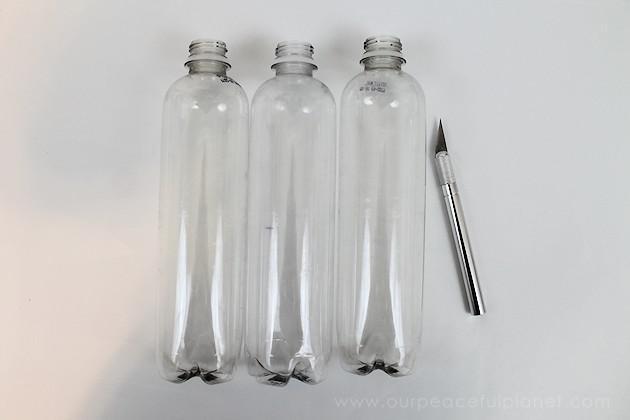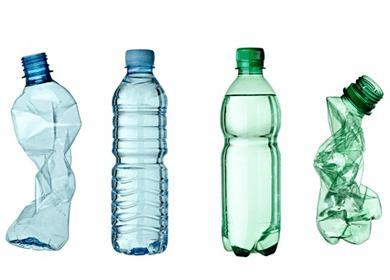The first image is the image on the left, the second image is the image on the right. Considering the images on both sides, is "There are exactly six bottles." valid? Answer yes or no. No. The first image is the image on the left, the second image is the image on the right. For the images shown, is this caption "In one image all the bottles are made of plastic." true? Answer yes or no. Yes. 